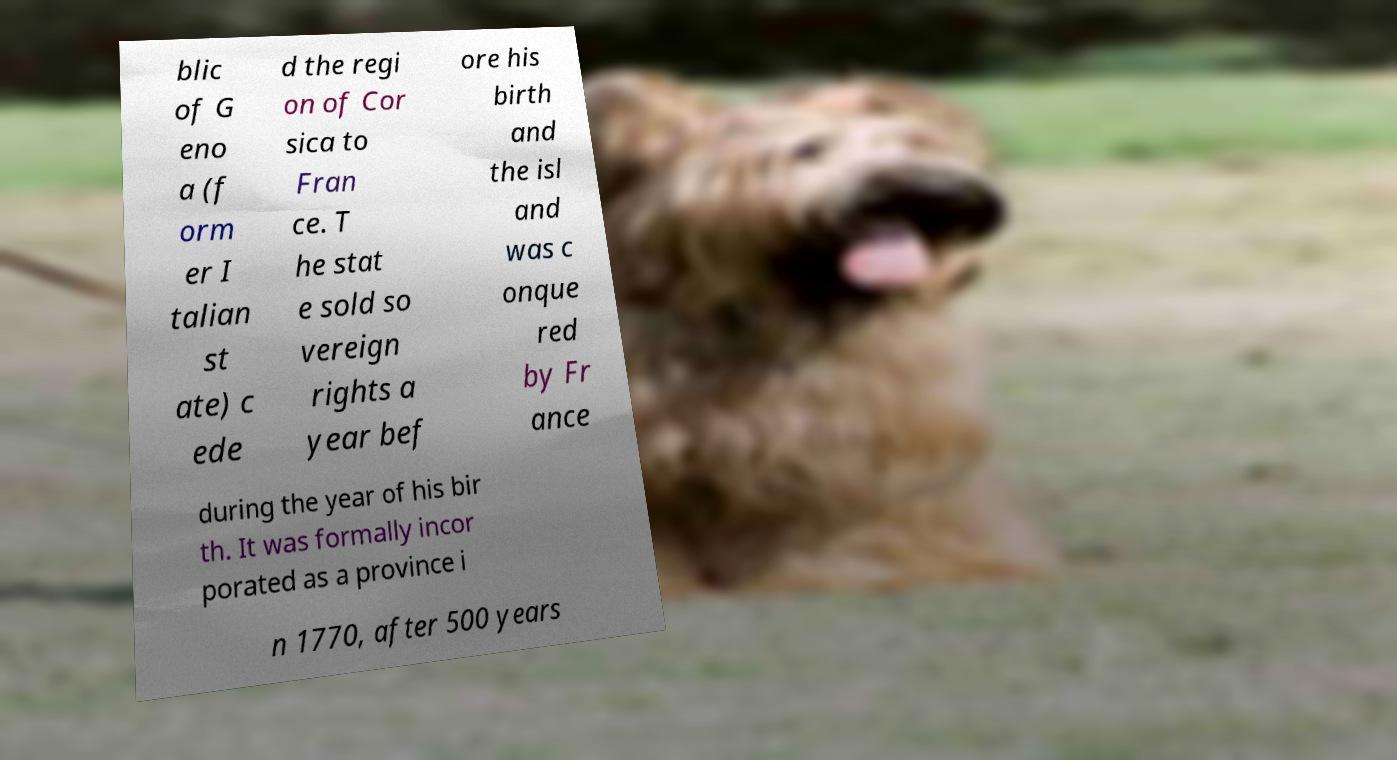For documentation purposes, I need the text within this image transcribed. Could you provide that? blic of G eno a (f orm er I talian st ate) c ede d the regi on of Cor sica to Fran ce. T he stat e sold so vereign rights a year bef ore his birth and the isl and was c onque red by Fr ance during the year of his bir th. It was formally incor porated as a province i n 1770, after 500 years 